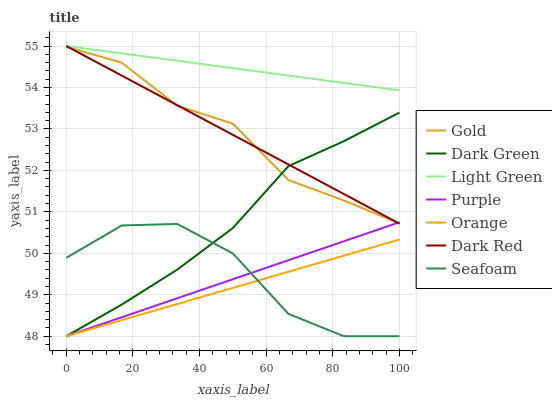Does Purple have the minimum area under the curve?
Answer yes or no. No. Does Purple have the maximum area under the curve?
Answer yes or no. No. Is Purple the smoothest?
Answer yes or no. No. Is Purple the roughest?
Answer yes or no. No. Does Dark Red have the lowest value?
Answer yes or no. No. Does Purple have the highest value?
Answer yes or no. No. Is Seafoam less than Dark Red?
Answer yes or no. Yes. Is Dark Red greater than Seafoam?
Answer yes or no. Yes. Does Seafoam intersect Dark Red?
Answer yes or no. No. 